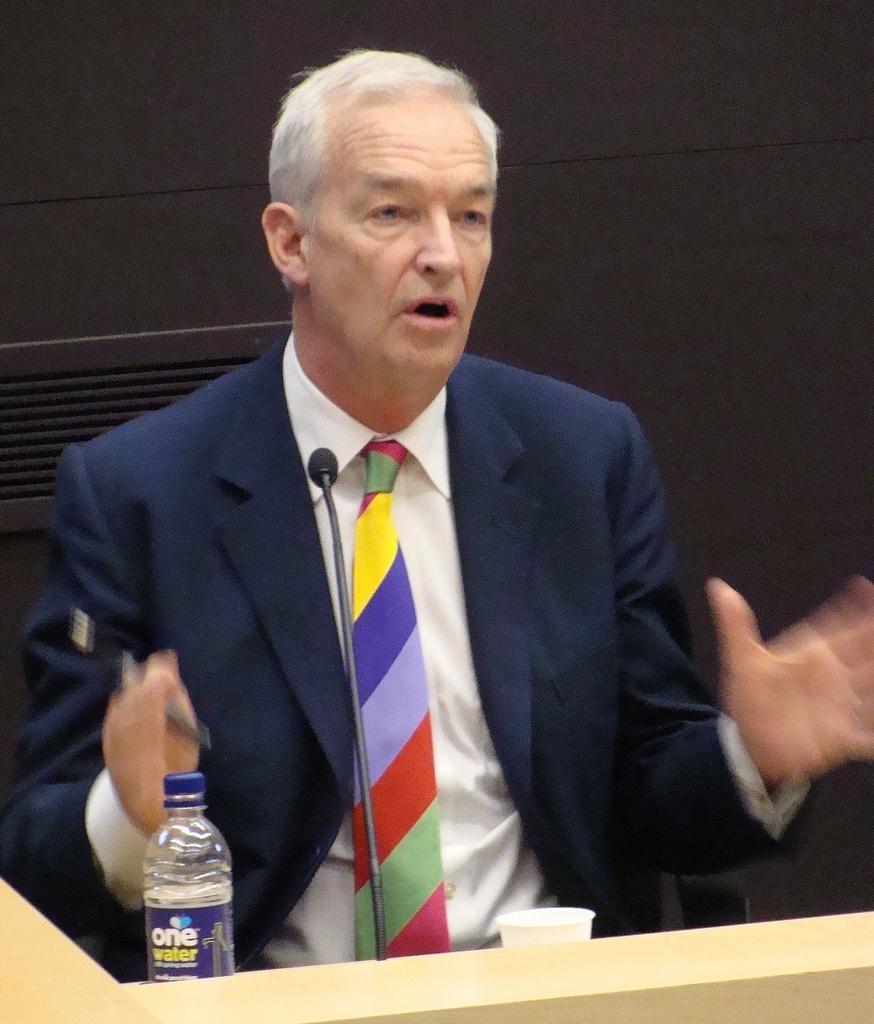Describe this image in one or two sentences. here we see a man speaking with the help of a microphone by standing near the podium 